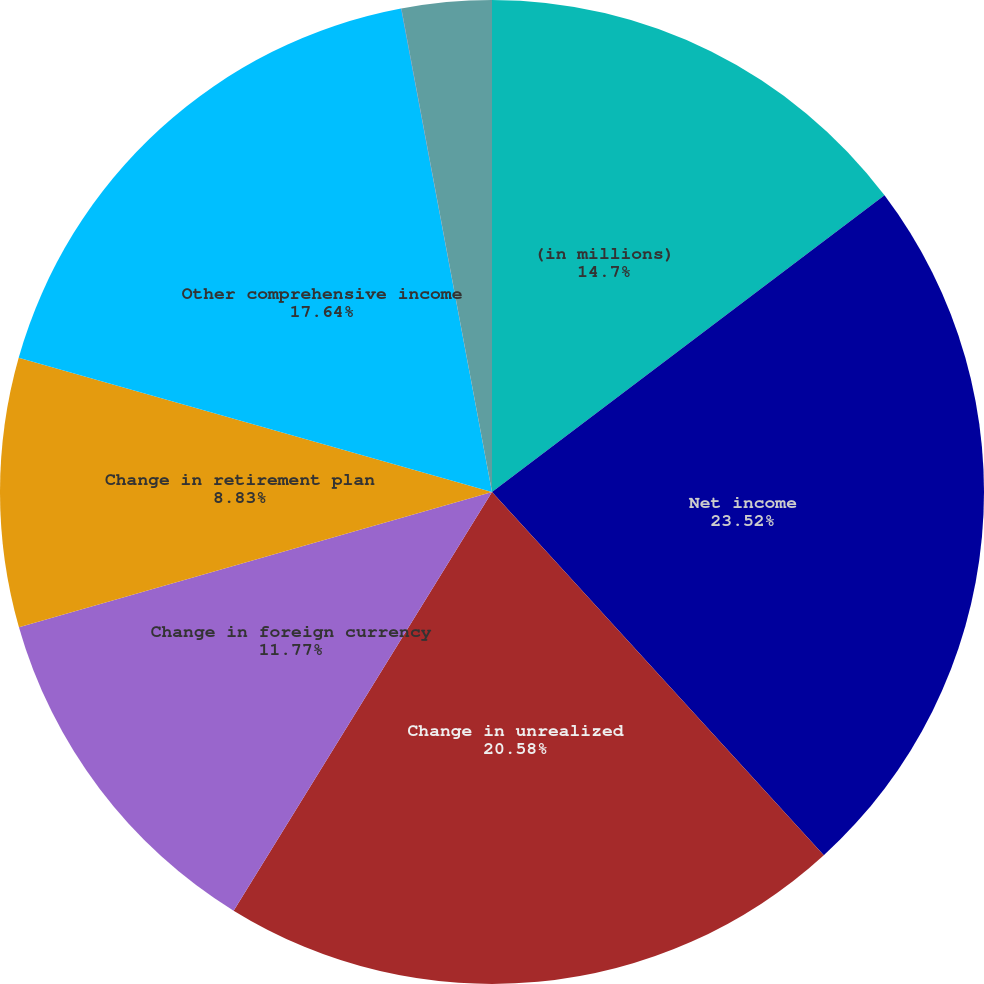Convert chart to OTSL. <chart><loc_0><loc_0><loc_500><loc_500><pie_chart><fcel>(in millions)<fcel>Net income<fcel>Change in unrealized<fcel>Change in foreign currency<fcel>Change in retirement plan<fcel>Other comprehensive income<fcel>Comprehensive income (loss)<fcel>Total comprehensive income<nl><fcel>14.7%<fcel>23.52%<fcel>20.58%<fcel>11.77%<fcel>8.83%<fcel>17.64%<fcel>0.01%<fcel>2.95%<nl></chart> 